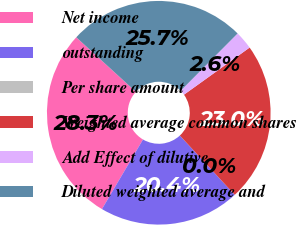<chart> <loc_0><loc_0><loc_500><loc_500><pie_chart><fcel>Net income<fcel>outstanding<fcel>Per share amount<fcel>Weighted average common shares<fcel>Add Effect of dilutive<fcel>Diluted weighted average and<nl><fcel>28.31%<fcel>20.37%<fcel>0.0%<fcel>23.02%<fcel>2.64%<fcel>25.66%<nl></chart> 